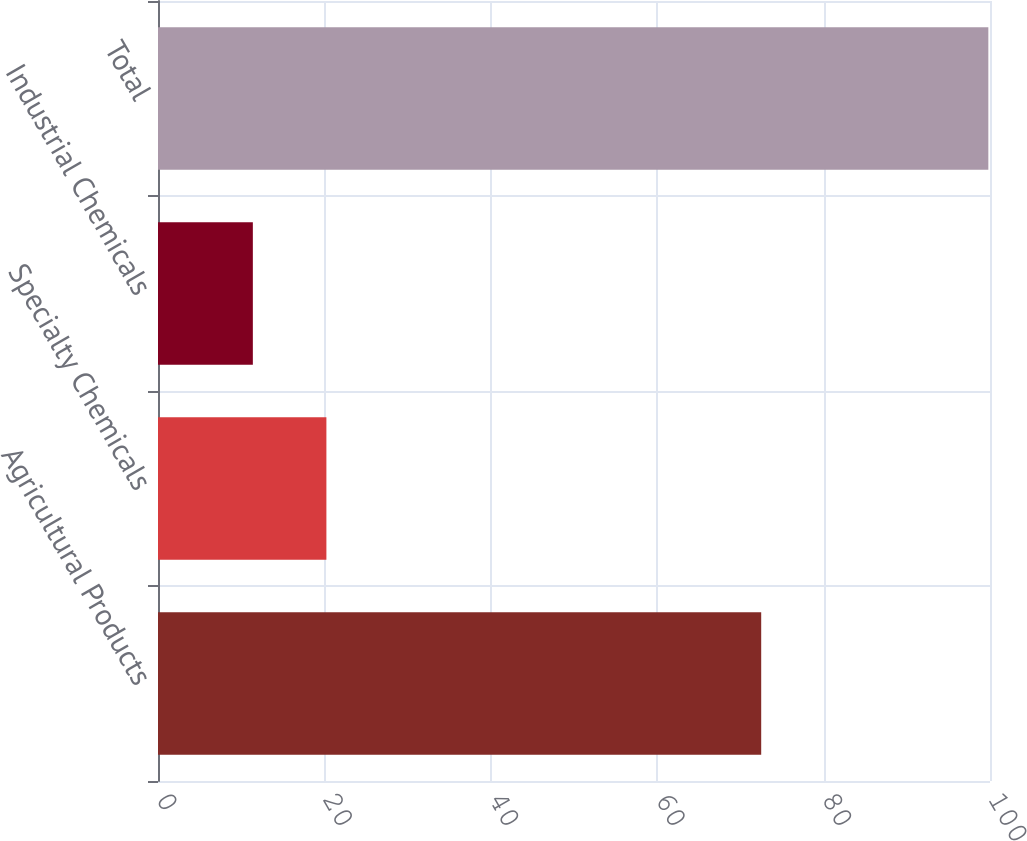Convert chart to OTSL. <chart><loc_0><loc_0><loc_500><loc_500><bar_chart><fcel>Agricultural Products<fcel>Specialty Chemicals<fcel>Industrial Chemicals<fcel>Total<nl><fcel>72.5<fcel>20.24<fcel>11.4<fcel>99.8<nl></chart> 